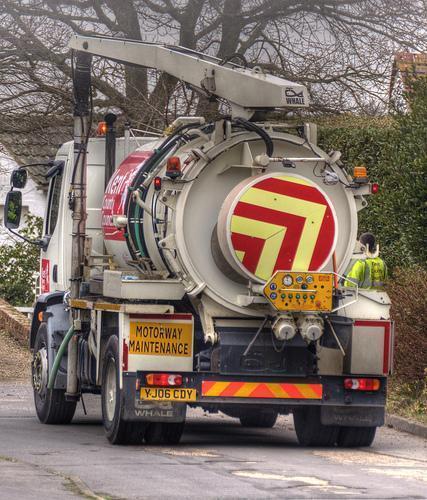How many tires are on the truck?
Give a very brief answer. 6. How many trucks are driving near beach?
Give a very brief answer. 0. 